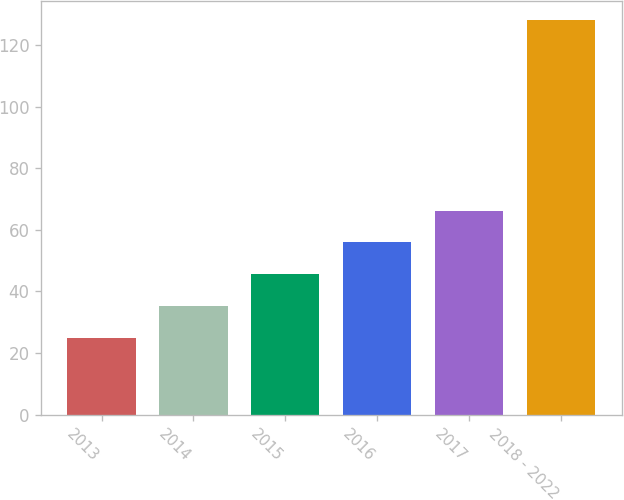Convert chart to OTSL. <chart><loc_0><loc_0><loc_500><loc_500><bar_chart><fcel>2013<fcel>2014<fcel>2015<fcel>2016<fcel>2017<fcel>2018 - 2022<nl><fcel>25<fcel>35.3<fcel>45.6<fcel>55.9<fcel>66.2<fcel>128<nl></chart> 